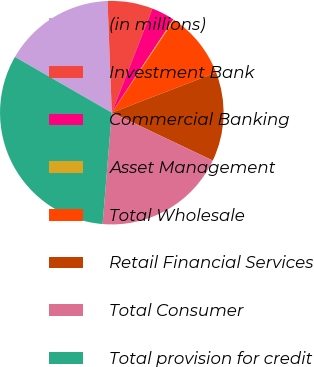Convert chart to OTSL. <chart><loc_0><loc_0><loc_500><loc_500><pie_chart><fcel>(in millions)<fcel>Investment Bank<fcel>Commercial Banking<fcel>Asset Management<fcel>Total Wholesale<fcel>Retail Financial Services<fcel>Total Consumer<fcel>Total provision for credit<nl><fcel>16.08%<fcel>6.53%<fcel>3.35%<fcel>0.16%<fcel>9.71%<fcel>12.9%<fcel>19.27%<fcel>32.0%<nl></chart> 